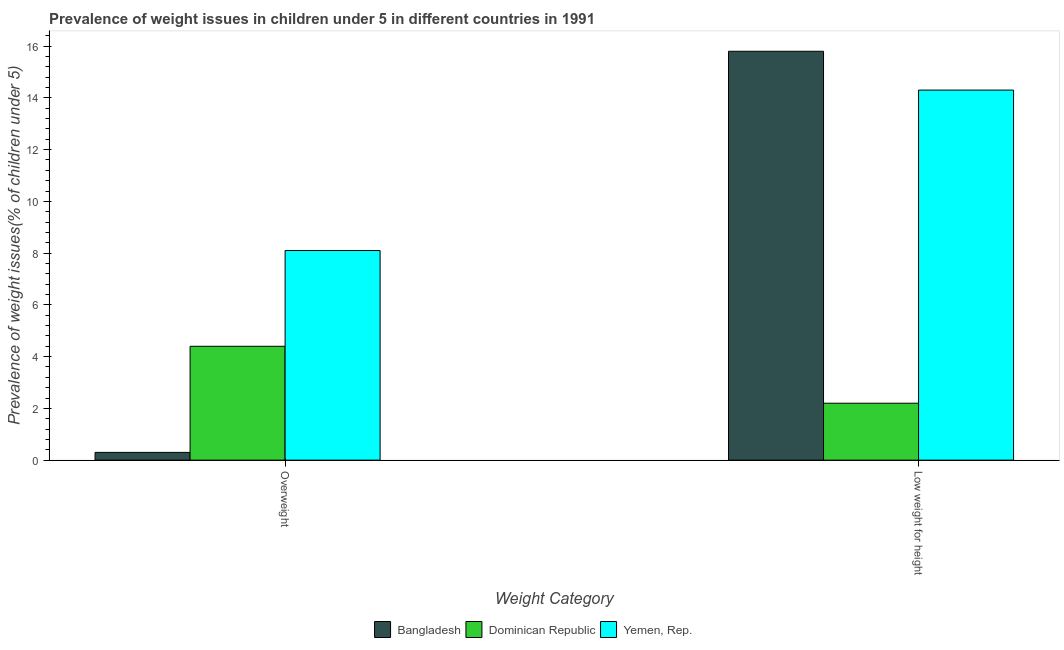Are the number of bars on each tick of the X-axis equal?
Ensure brevity in your answer.  Yes. How many bars are there on the 1st tick from the left?
Offer a very short reply. 3. What is the label of the 1st group of bars from the left?
Offer a terse response. Overweight. What is the percentage of overweight children in Yemen, Rep.?
Your answer should be compact. 8.1. Across all countries, what is the maximum percentage of underweight children?
Offer a very short reply. 15.8. Across all countries, what is the minimum percentage of overweight children?
Keep it short and to the point. 0.3. In which country was the percentage of overweight children minimum?
Keep it short and to the point. Bangladesh. What is the total percentage of underweight children in the graph?
Provide a succinct answer. 32.3. What is the difference between the percentage of overweight children in Bangladesh and that in Dominican Republic?
Your response must be concise. -4.1. What is the difference between the percentage of overweight children in Bangladesh and the percentage of underweight children in Yemen, Rep.?
Provide a short and direct response. -14. What is the average percentage of underweight children per country?
Provide a short and direct response. 10.77. What is the difference between the percentage of underweight children and percentage of overweight children in Bangladesh?
Your response must be concise. 15.5. What is the ratio of the percentage of underweight children in Dominican Republic to that in Yemen, Rep.?
Provide a short and direct response. 0.15. What does the 1st bar from the left in Overweight represents?
Your answer should be very brief. Bangladesh. What does the 1st bar from the right in Overweight represents?
Provide a succinct answer. Yemen, Rep. How many bars are there?
Ensure brevity in your answer.  6. Are all the bars in the graph horizontal?
Provide a succinct answer. No. What is the difference between two consecutive major ticks on the Y-axis?
Provide a succinct answer. 2. Does the graph contain any zero values?
Provide a short and direct response. No. Where does the legend appear in the graph?
Make the answer very short. Bottom center. How are the legend labels stacked?
Provide a succinct answer. Horizontal. What is the title of the graph?
Offer a very short reply. Prevalence of weight issues in children under 5 in different countries in 1991. Does "Cyprus" appear as one of the legend labels in the graph?
Keep it short and to the point. No. What is the label or title of the X-axis?
Your answer should be very brief. Weight Category. What is the label or title of the Y-axis?
Provide a succinct answer. Prevalence of weight issues(% of children under 5). What is the Prevalence of weight issues(% of children under 5) of Bangladesh in Overweight?
Provide a short and direct response. 0.3. What is the Prevalence of weight issues(% of children under 5) in Dominican Republic in Overweight?
Give a very brief answer. 4.4. What is the Prevalence of weight issues(% of children under 5) in Yemen, Rep. in Overweight?
Ensure brevity in your answer.  8.1. What is the Prevalence of weight issues(% of children under 5) of Bangladesh in Low weight for height?
Provide a short and direct response. 15.8. What is the Prevalence of weight issues(% of children under 5) in Dominican Republic in Low weight for height?
Your response must be concise. 2.2. What is the Prevalence of weight issues(% of children under 5) of Yemen, Rep. in Low weight for height?
Keep it short and to the point. 14.3. Across all Weight Category, what is the maximum Prevalence of weight issues(% of children under 5) of Bangladesh?
Offer a terse response. 15.8. Across all Weight Category, what is the maximum Prevalence of weight issues(% of children under 5) in Dominican Republic?
Keep it short and to the point. 4.4. Across all Weight Category, what is the maximum Prevalence of weight issues(% of children under 5) of Yemen, Rep.?
Keep it short and to the point. 14.3. Across all Weight Category, what is the minimum Prevalence of weight issues(% of children under 5) in Bangladesh?
Your answer should be compact. 0.3. Across all Weight Category, what is the minimum Prevalence of weight issues(% of children under 5) in Dominican Republic?
Your answer should be very brief. 2.2. Across all Weight Category, what is the minimum Prevalence of weight issues(% of children under 5) of Yemen, Rep.?
Your answer should be very brief. 8.1. What is the total Prevalence of weight issues(% of children under 5) in Yemen, Rep. in the graph?
Offer a terse response. 22.4. What is the difference between the Prevalence of weight issues(% of children under 5) in Bangladesh in Overweight and that in Low weight for height?
Your response must be concise. -15.5. What is the difference between the Prevalence of weight issues(% of children under 5) in Yemen, Rep. in Overweight and that in Low weight for height?
Offer a very short reply. -6.2. What is the difference between the Prevalence of weight issues(% of children under 5) of Bangladesh in Overweight and the Prevalence of weight issues(% of children under 5) of Yemen, Rep. in Low weight for height?
Give a very brief answer. -14. What is the difference between the Prevalence of weight issues(% of children under 5) in Dominican Republic in Overweight and the Prevalence of weight issues(% of children under 5) in Yemen, Rep. in Low weight for height?
Provide a short and direct response. -9.9. What is the average Prevalence of weight issues(% of children under 5) in Bangladesh per Weight Category?
Your answer should be compact. 8.05. What is the average Prevalence of weight issues(% of children under 5) of Dominican Republic per Weight Category?
Offer a terse response. 3.3. What is the average Prevalence of weight issues(% of children under 5) of Yemen, Rep. per Weight Category?
Your answer should be very brief. 11.2. What is the difference between the Prevalence of weight issues(% of children under 5) of Bangladesh and Prevalence of weight issues(% of children under 5) of Yemen, Rep. in Overweight?
Your answer should be compact. -7.8. What is the difference between the Prevalence of weight issues(% of children under 5) in Dominican Republic and Prevalence of weight issues(% of children under 5) in Yemen, Rep. in Overweight?
Provide a succinct answer. -3.7. What is the difference between the Prevalence of weight issues(% of children under 5) in Dominican Republic and Prevalence of weight issues(% of children under 5) in Yemen, Rep. in Low weight for height?
Provide a short and direct response. -12.1. What is the ratio of the Prevalence of weight issues(% of children under 5) in Bangladesh in Overweight to that in Low weight for height?
Provide a short and direct response. 0.02. What is the ratio of the Prevalence of weight issues(% of children under 5) in Dominican Republic in Overweight to that in Low weight for height?
Give a very brief answer. 2. What is the ratio of the Prevalence of weight issues(% of children under 5) of Yemen, Rep. in Overweight to that in Low weight for height?
Your response must be concise. 0.57. What is the difference between the highest and the second highest Prevalence of weight issues(% of children under 5) of Bangladesh?
Provide a succinct answer. 15.5. What is the difference between the highest and the second highest Prevalence of weight issues(% of children under 5) in Yemen, Rep.?
Keep it short and to the point. 6.2. What is the difference between the highest and the lowest Prevalence of weight issues(% of children under 5) in Dominican Republic?
Give a very brief answer. 2.2. What is the difference between the highest and the lowest Prevalence of weight issues(% of children under 5) in Yemen, Rep.?
Ensure brevity in your answer.  6.2. 